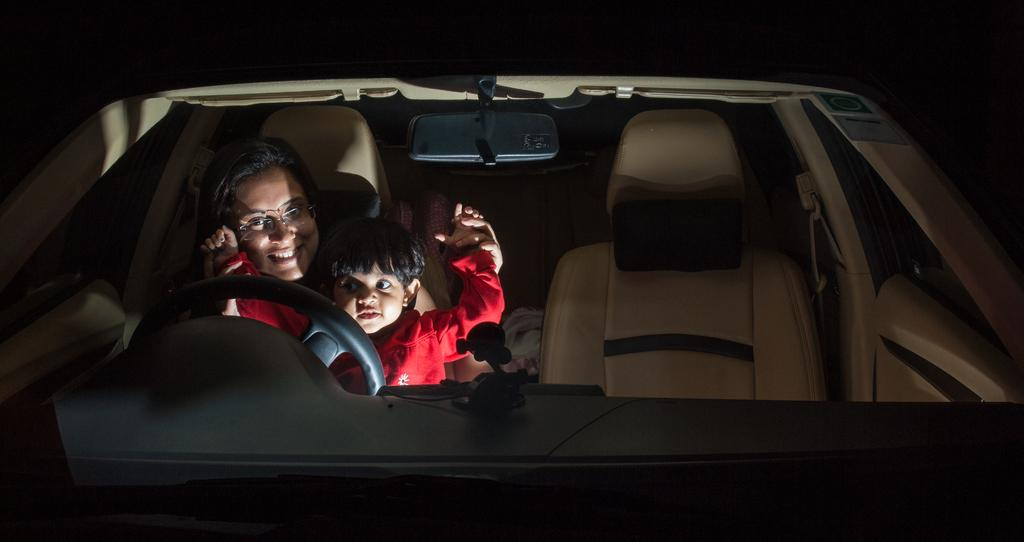What is the main subject of the image? There is a car in the image. Who is inside the car? A lady is sitting in the driver's seat of the car, and a child is sitting on her lap. How are the lady and the child feeling in the image? Both the lady and the child are smiling. What type of room is visible through the car's window in the image? There is no room visible through the car's window in the image; it only shows the lady and the child inside the car. 